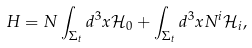Convert formula to latex. <formula><loc_0><loc_0><loc_500><loc_500>H = N \int _ { \Sigma _ { t } } d ^ { 3 } x \mathcal { H } _ { 0 } + \int _ { \Sigma _ { t } } d ^ { 3 } x N ^ { i } \mathcal { H } _ { i } ,</formula> 